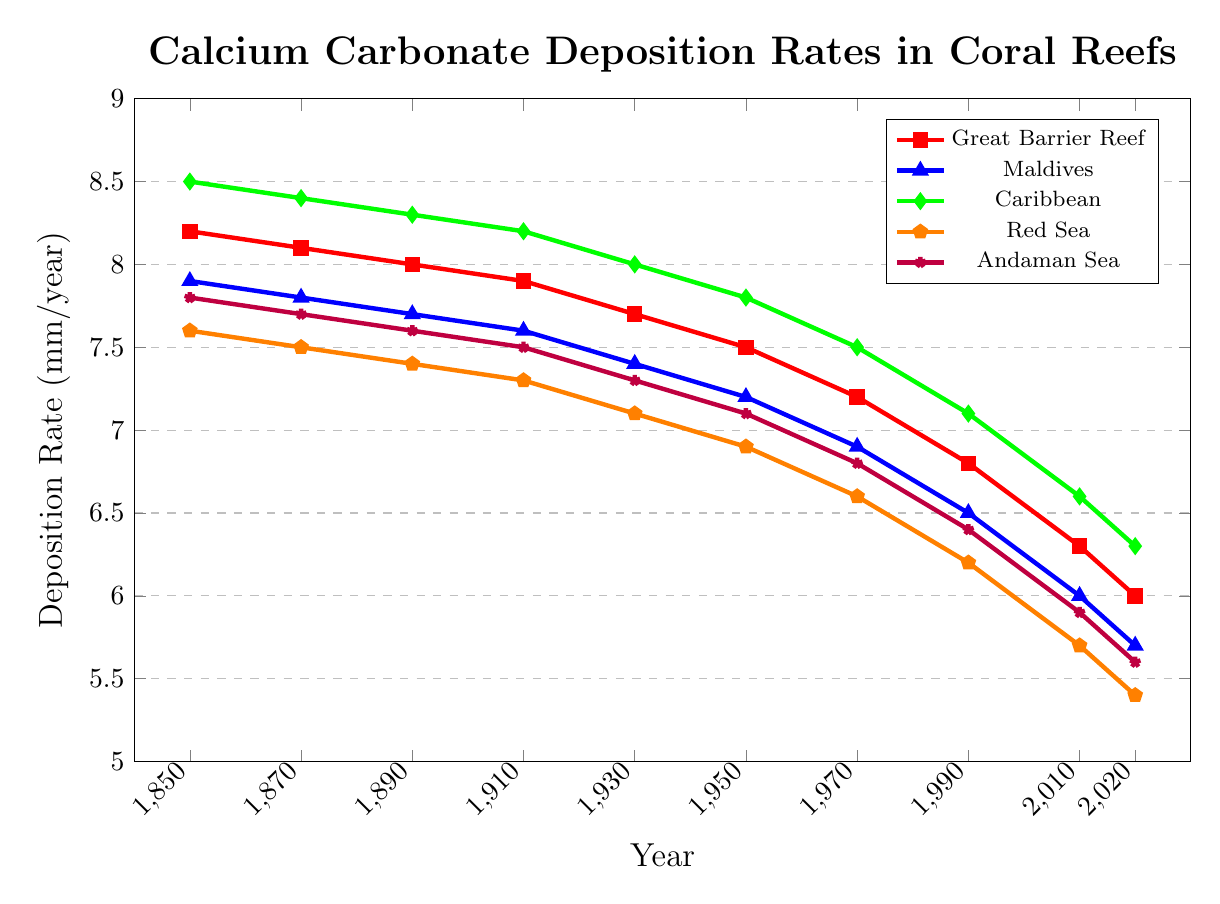What is the deposition rate of Calcium carbonate in the Great Barrier Reef in 2020? Looking at the red line marked with square symbols representing the Great Barrier Reef in the plot, we can find the value at the year 2020 to be 6.0 mm/year.
Answer: 6.0 mm/year Which coral reef had the highest deposition rate in 1850? In 1850, we compare the values at the start of each line: 8.2 (Great Barrier Reef), 7.9 (Maldives), 8.5 (Caribbean), 7.6 (Red Sea), and 7.8 (Andaman Sea). The Caribbean, marked with green diamonds, has the highest rate of 8.5 mm/year.
Answer: Caribbean By how much did the deposition rate decrease in the Maldives from 1850 to 2020? In 1850, the Maldives had a deposition rate of 7.9 mm/year (blue line with triangle symbols), and in 2020, it was 5.7 mm/year. The difference is 7.9 - 5.7 = 2.2 mm/year.
Answer: 2.2 mm/year Compare the deposition rates of the Caribbean and the Red Sea in 1910. Which one is higher, and by how much? In 1910, the Caribbean had a rate of 8.2 mm/year (green line with diamond symbols) and the Red Sea had 7.3 mm/year (orange line with pentagon symbols). The difference is 8.2 - 7.3 = 0.9 mm/year, with the Caribbean being higher.
Answer: Caribbean by 0.9 mm/year What is the average deposition rate of the Great Barrier Reef over all the years provided? Adding the values of the Great Barrier Reef (8.2, 8.1, 8.0, 7.9, 7.7, 7.5, 7.2, 6.8, 6.3, 6.0) and dividing by the number of years (10), we get (8.2 + 8.1 + 8.0 + 7.9 + 7.7 + 7.5 + 7.2 + 6.8 + 6.3 + 6.0) / 10 = 75.7 / 10 = 7.57 mm/year.
Answer: 7.57 mm/year Which coral reef has shown the steepest decline in deposition rate from 1850 to 2020? Observing the slopes of the lines from 1850 to 2020, the Caribbean Reef (green line with diamond symbols) decreased from 8.5 to 6.3 mm/year, a change of 2.2 mm/year, the Great Barrier Reef decreased by 2.2 mm/year, the Maldives by 2.2 mm/year, the Red Sea by 2.2 mm/year, and the Andaman Sea by 2.2 mm/year. All have shown an equal magnitude of decline.
Answer: All decreased by 2.2 mm/year What was the trend of deposition rate in the Red Sea from 1930 to 1990? From the plot, we see the orange line with pentagon symbols representing the Red Sea. The values in 1930 and 1990 are 7.1 and 6.2 mm/year respectively, indicating a downward trend.
Answer: Downward How much did the average deposition rate change for the Andaman Sea between 2000 and 2020? Since data exists only up to 2020, we refer to 2010 and 2020 for the Andaman Sea (purple line with star symbols) with values 5.9 and 5.6 mm/year. The difference is 5.9 - 5.6 = 0.3 mm/year.
Answer: Decreased by 0.3 mm/year 